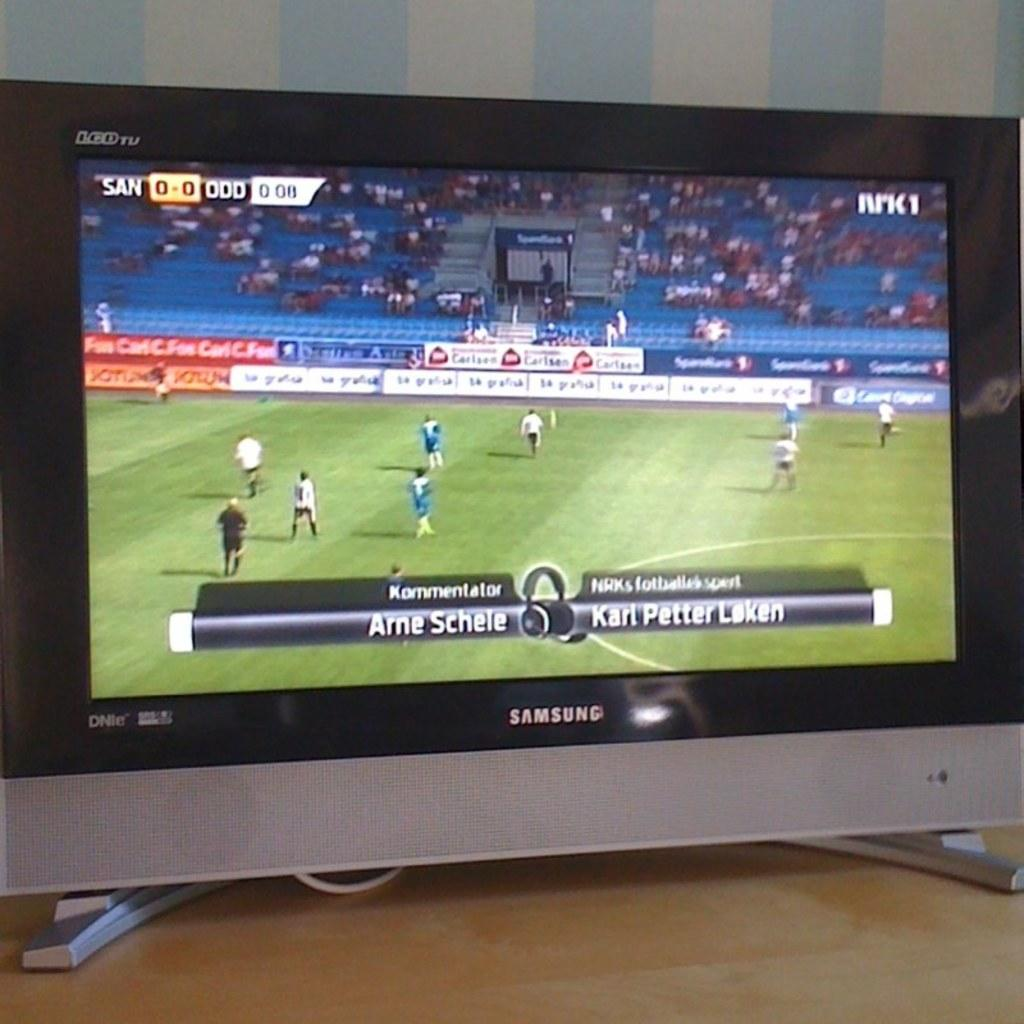Provide a one-sentence caption for the provided image. A samsung television that has a soccer game going on. 